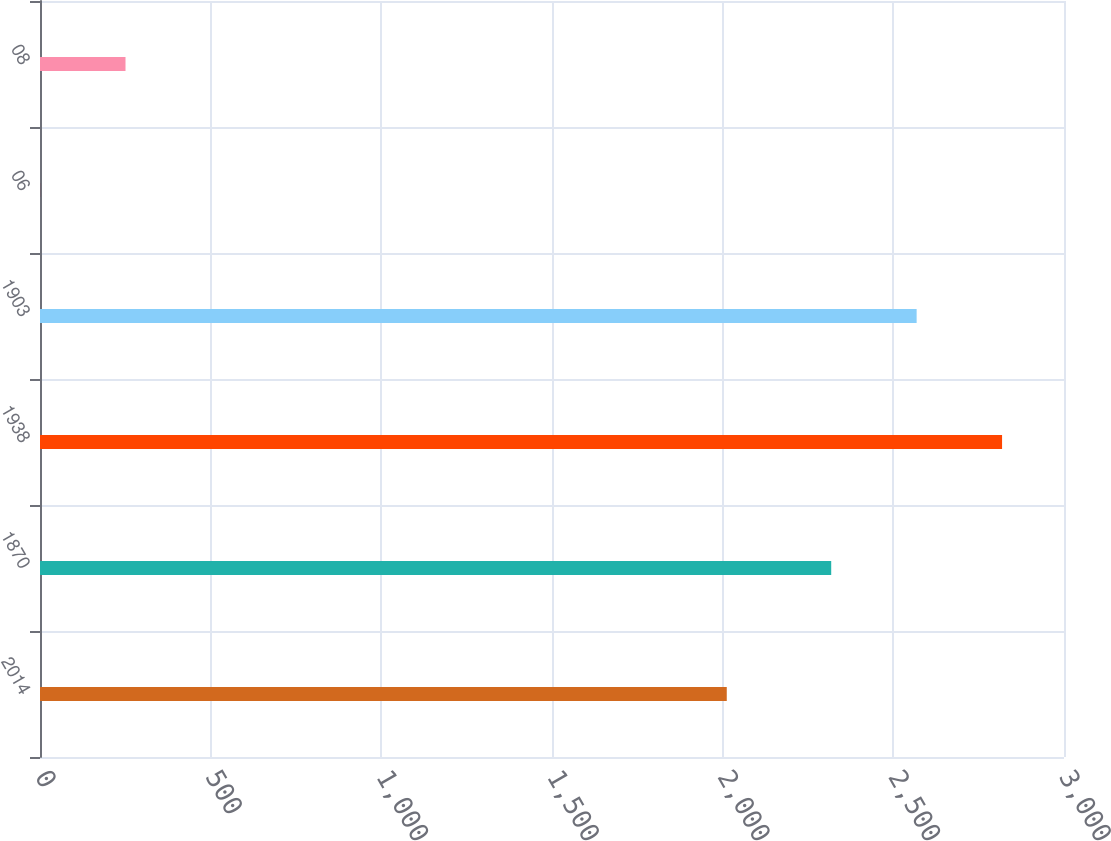<chart> <loc_0><loc_0><loc_500><loc_500><bar_chart><fcel>2014<fcel>1870<fcel>1938<fcel>1903<fcel>06<fcel>08<nl><fcel>2012<fcel>2318<fcel>2818.56<fcel>2568.28<fcel>0.22<fcel>250.5<nl></chart> 